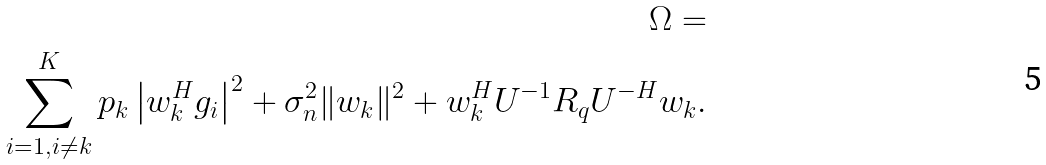Convert formula to latex. <formula><loc_0><loc_0><loc_500><loc_500>\Omega = \\ \sum _ { i = 1 , i \ne k } ^ { K } { p _ { k } \left | { { w } _ { k } ^ { H } } { g } _ { i } \right | ^ { 2 } } + \sigma _ { n } ^ { 2 } \| w _ { k } \| ^ { 2 } + w _ { k } ^ { H } U ^ { - 1 } R _ { q } U ^ { - H } w _ { k } .</formula> 